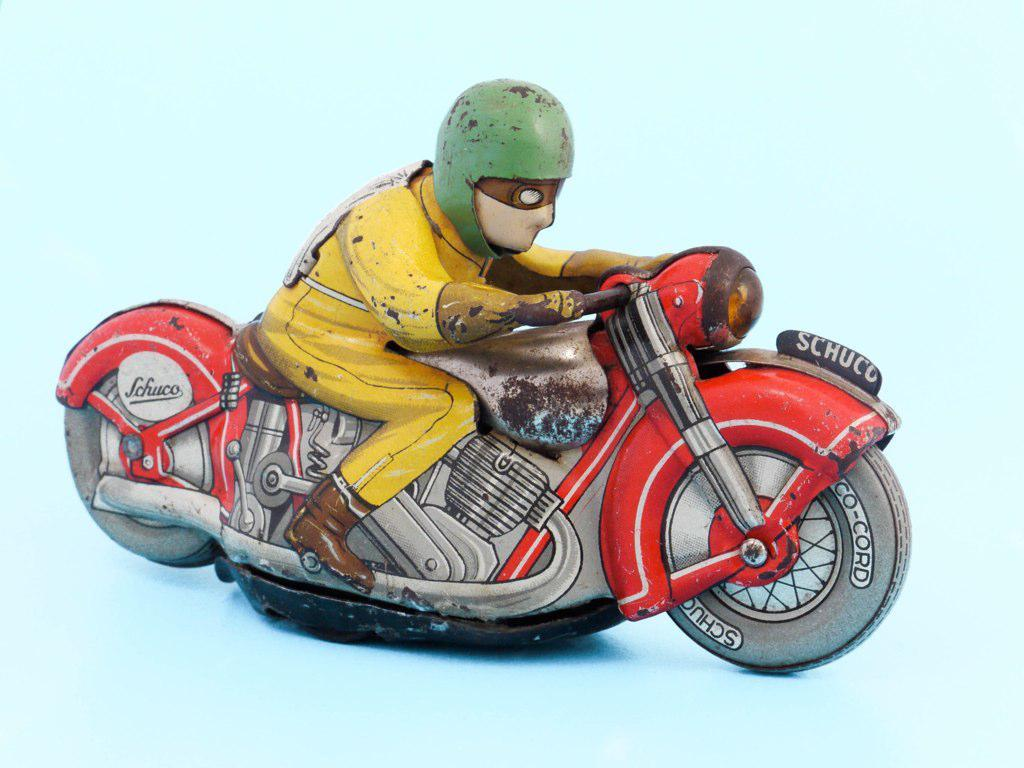What object can be seen in the image? There is a toy in the image. What type of vegetable is being used as a wrench in the image? There is no vegetable or wrench present in the image; it only features a toy. 